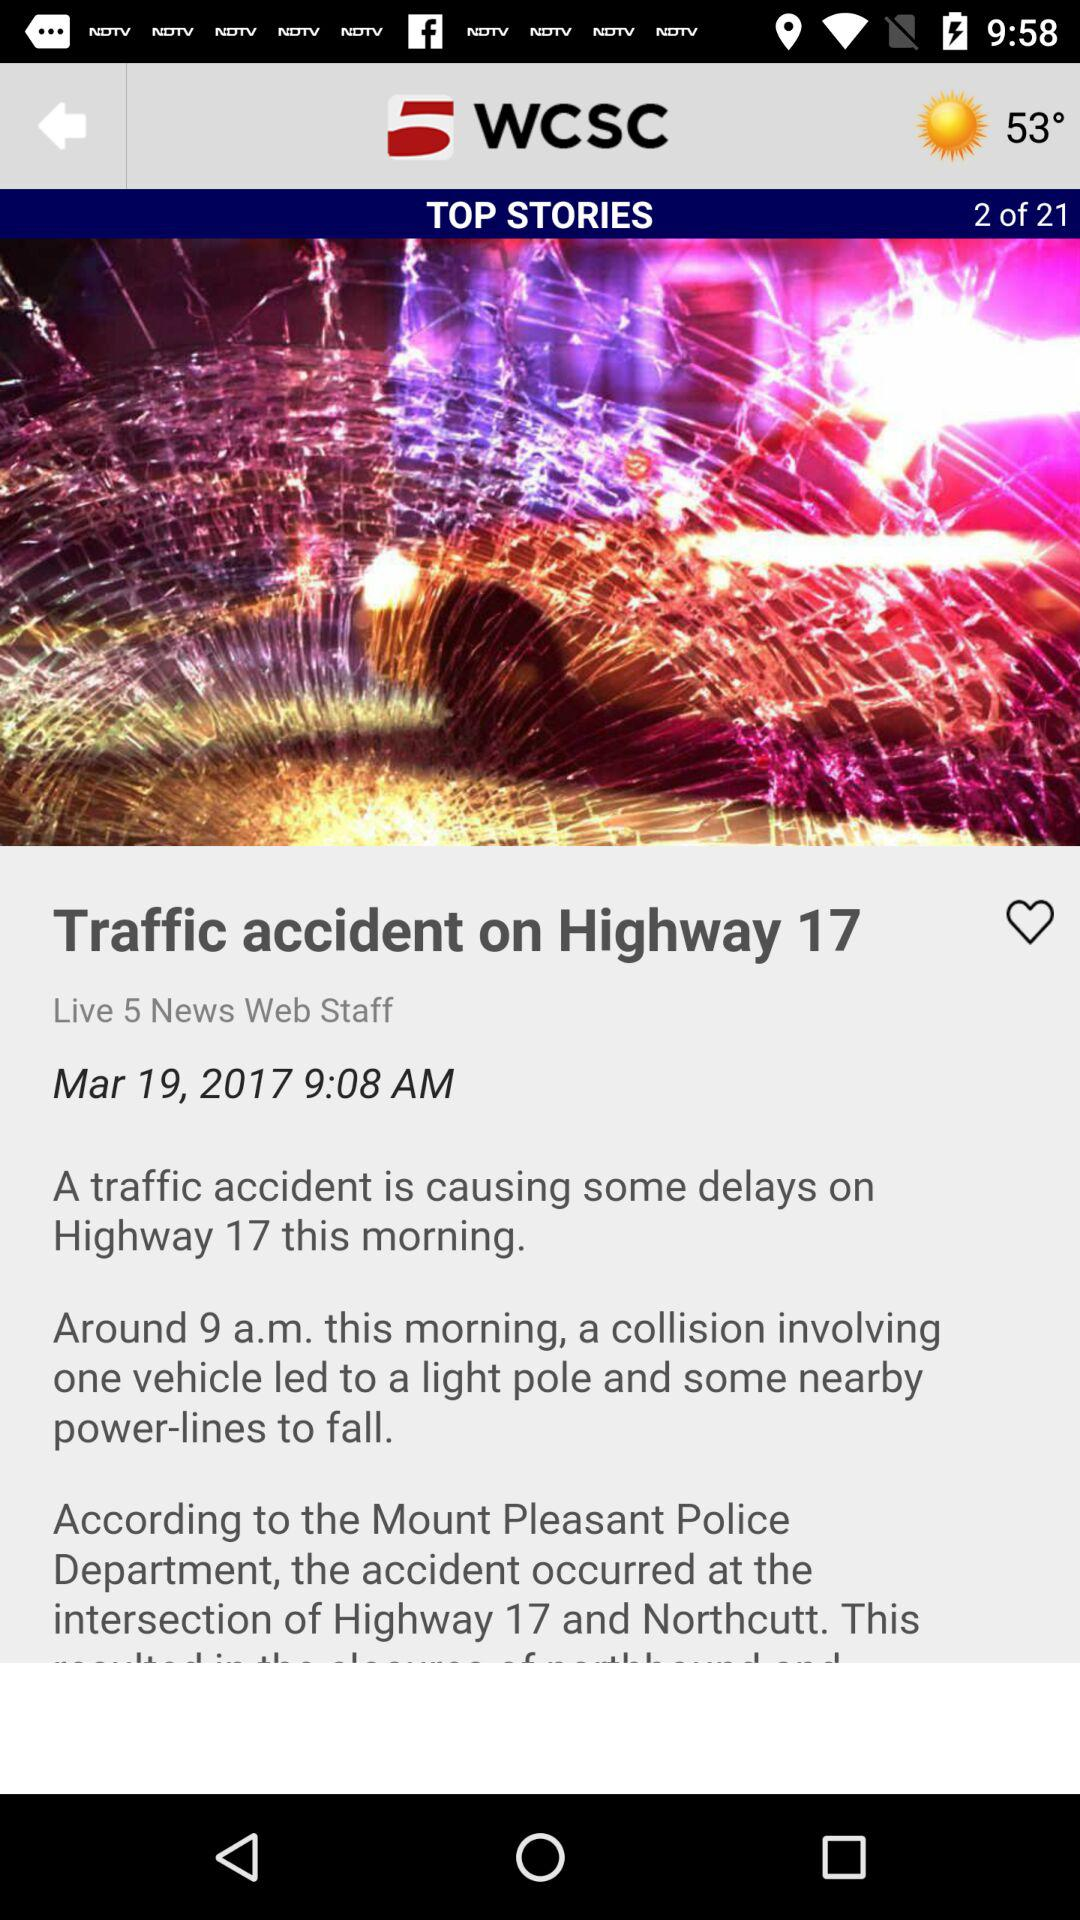What number of "TOP STORIES" is currently selected? The current selection is 2. 